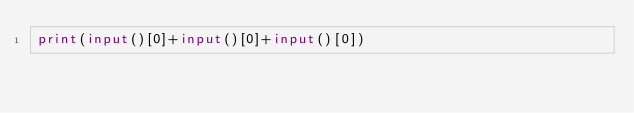Convert code to text. <code><loc_0><loc_0><loc_500><loc_500><_Python_>print(input()[0]+input()[0]+input()[0])</code> 